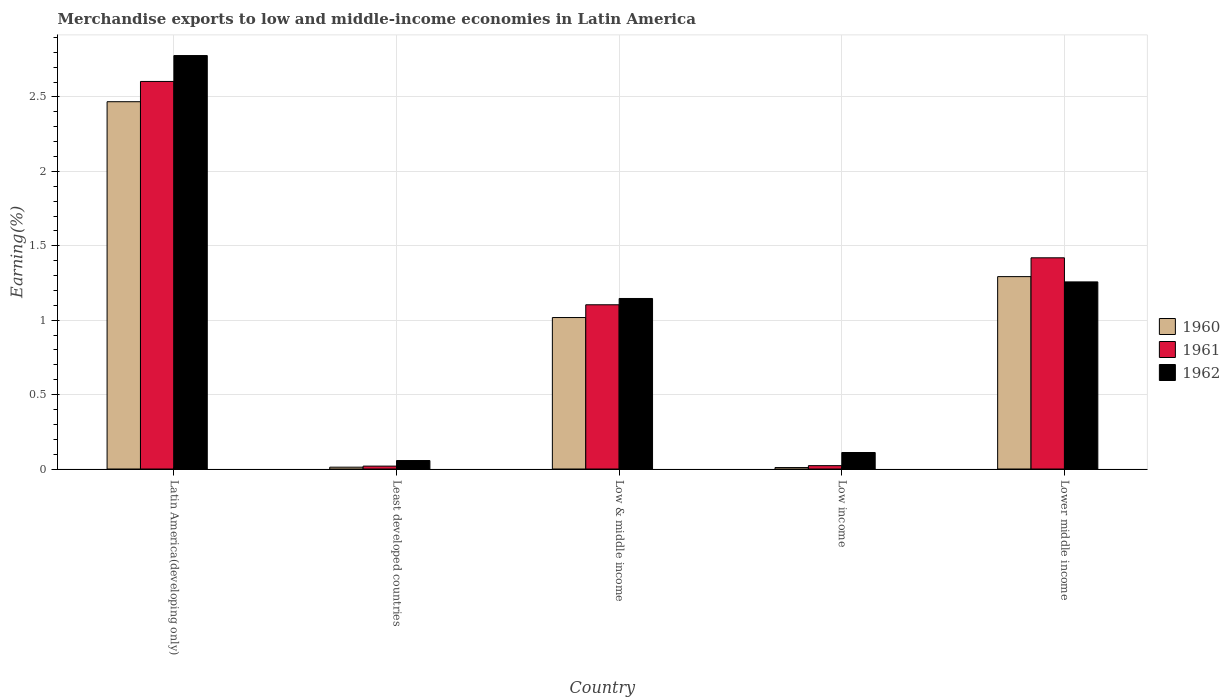How many groups of bars are there?
Ensure brevity in your answer.  5. Are the number of bars per tick equal to the number of legend labels?
Keep it short and to the point. Yes. What is the label of the 1st group of bars from the left?
Give a very brief answer. Latin America(developing only). In how many cases, is the number of bars for a given country not equal to the number of legend labels?
Offer a terse response. 0. What is the percentage of amount earned from merchandise exports in 1960 in Low income?
Make the answer very short. 0.01. Across all countries, what is the maximum percentage of amount earned from merchandise exports in 1960?
Provide a succinct answer. 2.47. Across all countries, what is the minimum percentage of amount earned from merchandise exports in 1961?
Offer a very short reply. 0.02. In which country was the percentage of amount earned from merchandise exports in 1960 maximum?
Ensure brevity in your answer.  Latin America(developing only). In which country was the percentage of amount earned from merchandise exports in 1961 minimum?
Ensure brevity in your answer.  Least developed countries. What is the total percentage of amount earned from merchandise exports in 1961 in the graph?
Offer a very short reply. 5.17. What is the difference between the percentage of amount earned from merchandise exports in 1962 in Latin America(developing only) and that in Least developed countries?
Ensure brevity in your answer.  2.72. What is the difference between the percentage of amount earned from merchandise exports in 1960 in Low & middle income and the percentage of amount earned from merchandise exports in 1962 in Least developed countries?
Ensure brevity in your answer.  0.96. What is the average percentage of amount earned from merchandise exports in 1962 per country?
Offer a very short reply. 1.07. What is the difference between the percentage of amount earned from merchandise exports of/in 1960 and percentage of amount earned from merchandise exports of/in 1961 in Lower middle income?
Provide a succinct answer. -0.13. In how many countries, is the percentage of amount earned from merchandise exports in 1960 greater than 0.9 %?
Provide a short and direct response. 3. What is the ratio of the percentage of amount earned from merchandise exports in 1961 in Least developed countries to that in Low & middle income?
Keep it short and to the point. 0.02. Is the percentage of amount earned from merchandise exports in 1960 in Least developed countries less than that in Low income?
Ensure brevity in your answer.  No. What is the difference between the highest and the second highest percentage of amount earned from merchandise exports in 1961?
Keep it short and to the point. -1.19. What is the difference between the highest and the lowest percentage of amount earned from merchandise exports in 1960?
Provide a succinct answer. 2.46. Is the sum of the percentage of amount earned from merchandise exports in 1962 in Least developed countries and Low income greater than the maximum percentage of amount earned from merchandise exports in 1961 across all countries?
Your response must be concise. No. What does the 1st bar from the right in Latin America(developing only) represents?
Provide a short and direct response. 1962. Is it the case that in every country, the sum of the percentage of amount earned from merchandise exports in 1961 and percentage of amount earned from merchandise exports in 1962 is greater than the percentage of amount earned from merchandise exports in 1960?
Your answer should be very brief. Yes. Does the graph contain any zero values?
Make the answer very short. No. How are the legend labels stacked?
Your answer should be compact. Vertical. What is the title of the graph?
Your answer should be compact. Merchandise exports to low and middle-income economies in Latin America. Does "1986" appear as one of the legend labels in the graph?
Offer a very short reply. No. What is the label or title of the X-axis?
Your answer should be compact. Country. What is the label or title of the Y-axis?
Provide a succinct answer. Earning(%). What is the Earning(%) in 1960 in Latin America(developing only)?
Make the answer very short. 2.47. What is the Earning(%) of 1961 in Latin America(developing only)?
Your answer should be compact. 2.6. What is the Earning(%) of 1962 in Latin America(developing only)?
Offer a terse response. 2.78. What is the Earning(%) of 1960 in Least developed countries?
Provide a succinct answer. 0.01. What is the Earning(%) in 1961 in Least developed countries?
Your answer should be very brief. 0.02. What is the Earning(%) in 1962 in Least developed countries?
Offer a terse response. 0.06. What is the Earning(%) in 1960 in Low & middle income?
Your answer should be compact. 1.02. What is the Earning(%) in 1961 in Low & middle income?
Provide a succinct answer. 1.1. What is the Earning(%) of 1962 in Low & middle income?
Your response must be concise. 1.15. What is the Earning(%) of 1960 in Low income?
Offer a very short reply. 0.01. What is the Earning(%) of 1961 in Low income?
Give a very brief answer. 0.02. What is the Earning(%) in 1962 in Low income?
Keep it short and to the point. 0.11. What is the Earning(%) of 1960 in Lower middle income?
Provide a succinct answer. 1.29. What is the Earning(%) in 1961 in Lower middle income?
Provide a short and direct response. 1.42. What is the Earning(%) in 1962 in Lower middle income?
Provide a succinct answer. 1.26. Across all countries, what is the maximum Earning(%) of 1960?
Provide a succinct answer. 2.47. Across all countries, what is the maximum Earning(%) of 1961?
Provide a succinct answer. 2.6. Across all countries, what is the maximum Earning(%) in 1962?
Your answer should be very brief. 2.78. Across all countries, what is the minimum Earning(%) of 1960?
Your answer should be compact. 0.01. Across all countries, what is the minimum Earning(%) in 1961?
Give a very brief answer. 0.02. Across all countries, what is the minimum Earning(%) of 1962?
Ensure brevity in your answer.  0.06. What is the total Earning(%) in 1960 in the graph?
Offer a terse response. 4.8. What is the total Earning(%) in 1961 in the graph?
Your answer should be compact. 5.17. What is the total Earning(%) of 1962 in the graph?
Offer a very short reply. 5.35. What is the difference between the Earning(%) of 1960 in Latin America(developing only) and that in Least developed countries?
Keep it short and to the point. 2.46. What is the difference between the Earning(%) of 1961 in Latin America(developing only) and that in Least developed countries?
Provide a short and direct response. 2.58. What is the difference between the Earning(%) of 1962 in Latin America(developing only) and that in Least developed countries?
Offer a terse response. 2.72. What is the difference between the Earning(%) in 1960 in Latin America(developing only) and that in Low & middle income?
Ensure brevity in your answer.  1.45. What is the difference between the Earning(%) in 1961 in Latin America(developing only) and that in Low & middle income?
Provide a short and direct response. 1.5. What is the difference between the Earning(%) in 1962 in Latin America(developing only) and that in Low & middle income?
Offer a very short reply. 1.63. What is the difference between the Earning(%) in 1960 in Latin America(developing only) and that in Low income?
Offer a very short reply. 2.46. What is the difference between the Earning(%) of 1961 in Latin America(developing only) and that in Low income?
Provide a short and direct response. 2.58. What is the difference between the Earning(%) of 1962 in Latin America(developing only) and that in Low income?
Offer a terse response. 2.67. What is the difference between the Earning(%) in 1960 in Latin America(developing only) and that in Lower middle income?
Offer a terse response. 1.18. What is the difference between the Earning(%) in 1961 in Latin America(developing only) and that in Lower middle income?
Give a very brief answer. 1.19. What is the difference between the Earning(%) of 1962 in Latin America(developing only) and that in Lower middle income?
Keep it short and to the point. 1.52. What is the difference between the Earning(%) in 1960 in Least developed countries and that in Low & middle income?
Offer a terse response. -1.01. What is the difference between the Earning(%) of 1961 in Least developed countries and that in Low & middle income?
Ensure brevity in your answer.  -1.08. What is the difference between the Earning(%) in 1962 in Least developed countries and that in Low & middle income?
Make the answer very short. -1.09. What is the difference between the Earning(%) in 1960 in Least developed countries and that in Low income?
Ensure brevity in your answer.  0. What is the difference between the Earning(%) in 1961 in Least developed countries and that in Low income?
Your answer should be compact. -0. What is the difference between the Earning(%) of 1962 in Least developed countries and that in Low income?
Ensure brevity in your answer.  -0.05. What is the difference between the Earning(%) in 1960 in Least developed countries and that in Lower middle income?
Provide a succinct answer. -1.28. What is the difference between the Earning(%) of 1961 in Least developed countries and that in Lower middle income?
Your answer should be compact. -1.4. What is the difference between the Earning(%) of 1962 in Least developed countries and that in Lower middle income?
Your answer should be very brief. -1.2. What is the difference between the Earning(%) in 1961 in Low & middle income and that in Low income?
Your response must be concise. 1.08. What is the difference between the Earning(%) in 1962 in Low & middle income and that in Low income?
Give a very brief answer. 1.03. What is the difference between the Earning(%) of 1960 in Low & middle income and that in Lower middle income?
Keep it short and to the point. -0.27. What is the difference between the Earning(%) in 1961 in Low & middle income and that in Lower middle income?
Offer a very short reply. -0.32. What is the difference between the Earning(%) in 1962 in Low & middle income and that in Lower middle income?
Provide a short and direct response. -0.11. What is the difference between the Earning(%) of 1960 in Low income and that in Lower middle income?
Provide a short and direct response. -1.28. What is the difference between the Earning(%) in 1961 in Low income and that in Lower middle income?
Your response must be concise. -1.4. What is the difference between the Earning(%) of 1962 in Low income and that in Lower middle income?
Your answer should be very brief. -1.15. What is the difference between the Earning(%) of 1960 in Latin America(developing only) and the Earning(%) of 1961 in Least developed countries?
Provide a short and direct response. 2.45. What is the difference between the Earning(%) of 1960 in Latin America(developing only) and the Earning(%) of 1962 in Least developed countries?
Keep it short and to the point. 2.41. What is the difference between the Earning(%) in 1961 in Latin America(developing only) and the Earning(%) in 1962 in Least developed countries?
Your response must be concise. 2.55. What is the difference between the Earning(%) of 1960 in Latin America(developing only) and the Earning(%) of 1961 in Low & middle income?
Keep it short and to the point. 1.36. What is the difference between the Earning(%) in 1960 in Latin America(developing only) and the Earning(%) in 1962 in Low & middle income?
Make the answer very short. 1.32. What is the difference between the Earning(%) in 1961 in Latin America(developing only) and the Earning(%) in 1962 in Low & middle income?
Provide a succinct answer. 1.46. What is the difference between the Earning(%) in 1960 in Latin America(developing only) and the Earning(%) in 1961 in Low income?
Your answer should be compact. 2.45. What is the difference between the Earning(%) in 1960 in Latin America(developing only) and the Earning(%) in 1962 in Low income?
Make the answer very short. 2.36. What is the difference between the Earning(%) of 1961 in Latin America(developing only) and the Earning(%) of 1962 in Low income?
Keep it short and to the point. 2.49. What is the difference between the Earning(%) in 1960 in Latin America(developing only) and the Earning(%) in 1961 in Lower middle income?
Ensure brevity in your answer.  1.05. What is the difference between the Earning(%) of 1960 in Latin America(developing only) and the Earning(%) of 1962 in Lower middle income?
Keep it short and to the point. 1.21. What is the difference between the Earning(%) of 1961 in Latin America(developing only) and the Earning(%) of 1962 in Lower middle income?
Your response must be concise. 1.35. What is the difference between the Earning(%) in 1960 in Least developed countries and the Earning(%) in 1961 in Low & middle income?
Offer a very short reply. -1.09. What is the difference between the Earning(%) in 1960 in Least developed countries and the Earning(%) in 1962 in Low & middle income?
Keep it short and to the point. -1.13. What is the difference between the Earning(%) in 1961 in Least developed countries and the Earning(%) in 1962 in Low & middle income?
Provide a succinct answer. -1.13. What is the difference between the Earning(%) of 1960 in Least developed countries and the Earning(%) of 1961 in Low income?
Offer a terse response. -0.01. What is the difference between the Earning(%) in 1960 in Least developed countries and the Earning(%) in 1962 in Low income?
Provide a short and direct response. -0.1. What is the difference between the Earning(%) of 1961 in Least developed countries and the Earning(%) of 1962 in Low income?
Give a very brief answer. -0.09. What is the difference between the Earning(%) of 1960 in Least developed countries and the Earning(%) of 1961 in Lower middle income?
Keep it short and to the point. -1.41. What is the difference between the Earning(%) in 1960 in Least developed countries and the Earning(%) in 1962 in Lower middle income?
Make the answer very short. -1.25. What is the difference between the Earning(%) of 1961 in Least developed countries and the Earning(%) of 1962 in Lower middle income?
Offer a very short reply. -1.24. What is the difference between the Earning(%) of 1960 in Low & middle income and the Earning(%) of 1962 in Low income?
Offer a very short reply. 0.91. What is the difference between the Earning(%) in 1961 in Low & middle income and the Earning(%) in 1962 in Low income?
Ensure brevity in your answer.  0.99. What is the difference between the Earning(%) of 1960 in Low & middle income and the Earning(%) of 1961 in Lower middle income?
Offer a terse response. -0.4. What is the difference between the Earning(%) in 1960 in Low & middle income and the Earning(%) in 1962 in Lower middle income?
Ensure brevity in your answer.  -0.24. What is the difference between the Earning(%) in 1961 in Low & middle income and the Earning(%) in 1962 in Lower middle income?
Make the answer very short. -0.15. What is the difference between the Earning(%) in 1960 in Low income and the Earning(%) in 1961 in Lower middle income?
Your answer should be very brief. -1.41. What is the difference between the Earning(%) of 1960 in Low income and the Earning(%) of 1962 in Lower middle income?
Provide a short and direct response. -1.25. What is the difference between the Earning(%) of 1961 in Low income and the Earning(%) of 1962 in Lower middle income?
Make the answer very short. -1.23. What is the average Earning(%) in 1960 per country?
Your answer should be compact. 0.96. What is the average Earning(%) in 1961 per country?
Your answer should be compact. 1.03. What is the average Earning(%) in 1962 per country?
Keep it short and to the point. 1.07. What is the difference between the Earning(%) of 1960 and Earning(%) of 1961 in Latin America(developing only)?
Offer a terse response. -0.14. What is the difference between the Earning(%) of 1960 and Earning(%) of 1962 in Latin America(developing only)?
Provide a succinct answer. -0.31. What is the difference between the Earning(%) in 1961 and Earning(%) in 1962 in Latin America(developing only)?
Your answer should be very brief. -0.17. What is the difference between the Earning(%) of 1960 and Earning(%) of 1961 in Least developed countries?
Offer a very short reply. -0.01. What is the difference between the Earning(%) of 1960 and Earning(%) of 1962 in Least developed countries?
Your answer should be compact. -0.04. What is the difference between the Earning(%) of 1961 and Earning(%) of 1962 in Least developed countries?
Give a very brief answer. -0.04. What is the difference between the Earning(%) of 1960 and Earning(%) of 1961 in Low & middle income?
Ensure brevity in your answer.  -0.09. What is the difference between the Earning(%) of 1960 and Earning(%) of 1962 in Low & middle income?
Make the answer very short. -0.13. What is the difference between the Earning(%) of 1961 and Earning(%) of 1962 in Low & middle income?
Offer a very short reply. -0.04. What is the difference between the Earning(%) of 1960 and Earning(%) of 1961 in Low income?
Give a very brief answer. -0.01. What is the difference between the Earning(%) of 1960 and Earning(%) of 1962 in Low income?
Provide a short and direct response. -0.1. What is the difference between the Earning(%) in 1961 and Earning(%) in 1962 in Low income?
Offer a terse response. -0.09. What is the difference between the Earning(%) of 1960 and Earning(%) of 1961 in Lower middle income?
Make the answer very short. -0.13. What is the difference between the Earning(%) in 1960 and Earning(%) in 1962 in Lower middle income?
Give a very brief answer. 0.04. What is the difference between the Earning(%) of 1961 and Earning(%) of 1962 in Lower middle income?
Ensure brevity in your answer.  0.16. What is the ratio of the Earning(%) of 1960 in Latin America(developing only) to that in Least developed countries?
Provide a short and direct response. 199.93. What is the ratio of the Earning(%) of 1961 in Latin America(developing only) to that in Least developed countries?
Offer a terse response. 133.49. What is the ratio of the Earning(%) of 1962 in Latin America(developing only) to that in Least developed countries?
Ensure brevity in your answer.  48.79. What is the ratio of the Earning(%) of 1960 in Latin America(developing only) to that in Low & middle income?
Offer a very short reply. 2.42. What is the ratio of the Earning(%) of 1961 in Latin America(developing only) to that in Low & middle income?
Your response must be concise. 2.36. What is the ratio of the Earning(%) of 1962 in Latin America(developing only) to that in Low & middle income?
Ensure brevity in your answer.  2.42. What is the ratio of the Earning(%) of 1960 in Latin America(developing only) to that in Low income?
Offer a very short reply. 251.73. What is the ratio of the Earning(%) in 1961 in Latin America(developing only) to that in Low income?
Ensure brevity in your answer.  115.27. What is the ratio of the Earning(%) of 1962 in Latin America(developing only) to that in Low income?
Make the answer very short. 25.04. What is the ratio of the Earning(%) of 1960 in Latin America(developing only) to that in Lower middle income?
Your answer should be compact. 1.91. What is the ratio of the Earning(%) of 1961 in Latin America(developing only) to that in Lower middle income?
Offer a terse response. 1.84. What is the ratio of the Earning(%) in 1962 in Latin America(developing only) to that in Lower middle income?
Provide a succinct answer. 2.21. What is the ratio of the Earning(%) of 1960 in Least developed countries to that in Low & middle income?
Your response must be concise. 0.01. What is the ratio of the Earning(%) of 1961 in Least developed countries to that in Low & middle income?
Offer a terse response. 0.02. What is the ratio of the Earning(%) in 1962 in Least developed countries to that in Low & middle income?
Offer a very short reply. 0.05. What is the ratio of the Earning(%) of 1960 in Least developed countries to that in Low income?
Give a very brief answer. 1.26. What is the ratio of the Earning(%) in 1961 in Least developed countries to that in Low income?
Provide a succinct answer. 0.86. What is the ratio of the Earning(%) of 1962 in Least developed countries to that in Low income?
Provide a succinct answer. 0.51. What is the ratio of the Earning(%) in 1960 in Least developed countries to that in Lower middle income?
Your response must be concise. 0.01. What is the ratio of the Earning(%) of 1961 in Least developed countries to that in Lower middle income?
Offer a terse response. 0.01. What is the ratio of the Earning(%) of 1962 in Least developed countries to that in Lower middle income?
Offer a very short reply. 0.05. What is the ratio of the Earning(%) in 1960 in Low & middle income to that in Low income?
Your answer should be compact. 103.82. What is the ratio of the Earning(%) in 1961 in Low & middle income to that in Low income?
Offer a terse response. 48.85. What is the ratio of the Earning(%) in 1962 in Low & middle income to that in Low income?
Your answer should be compact. 10.33. What is the ratio of the Earning(%) of 1960 in Low & middle income to that in Lower middle income?
Your answer should be very brief. 0.79. What is the ratio of the Earning(%) of 1961 in Low & middle income to that in Lower middle income?
Make the answer very short. 0.78. What is the ratio of the Earning(%) in 1962 in Low & middle income to that in Lower middle income?
Your answer should be very brief. 0.91. What is the ratio of the Earning(%) of 1960 in Low income to that in Lower middle income?
Provide a succinct answer. 0.01. What is the ratio of the Earning(%) of 1961 in Low income to that in Lower middle income?
Keep it short and to the point. 0.02. What is the ratio of the Earning(%) of 1962 in Low income to that in Lower middle income?
Provide a succinct answer. 0.09. What is the difference between the highest and the second highest Earning(%) of 1960?
Ensure brevity in your answer.  1.18. What is the difference between the highest and the second highest Earning(%) in 1961?
Keep it short and to the point. 1.19. What is the difference between the highest and the second highest Earning(%) of 1962?
Make the answer very short. 1.52. What is the difference between the highest and the lowest Earning(%) of 1960?
Make the answer very short. 2.46. What is the difference between the highest and the lowest Earning(%) in 1961?
Make the answer very short. 2.58. What is the difference between the highest and the lowest Earning(%) in 1962?
Your response must be concise. 2.72. 